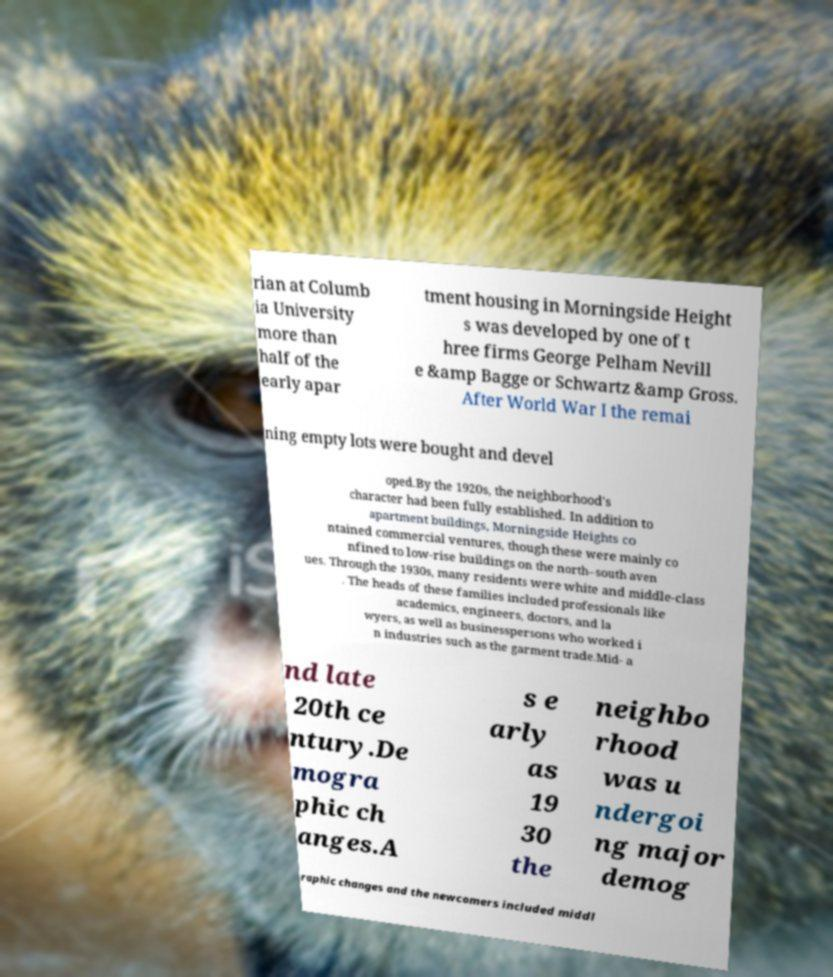Could you extract and type out the text from this image? rian at Columb ia University more than half of the early apar tment housing in Morningside Height s was developed by one of t hree firms George Pelham Nevill e &amp Bagge or Schwartz &amp Gross. After World War I the remai ning empty lots were bought and devel oped.By the 1920s, the neighborhood's character had been fully established. In addition to apartment buildings, Morningside Heights co ntained commercial ventures, though these were mainly co nfined to low-rise buildings on the north–south aven ues. Through the 1930s, many residents were white and middle-class . The heads of these families included professionals like academics, engineers, doctors, and la wyers, as well as businesspersons who worked i n industries such as the garment trade.Mid- a nd late 20th ce ntury.De mogra phic ch anges.A s e arly as 19 30 the neighbo rhood was u ndergoi ng major demog raphic changes and the newcomers included middl 